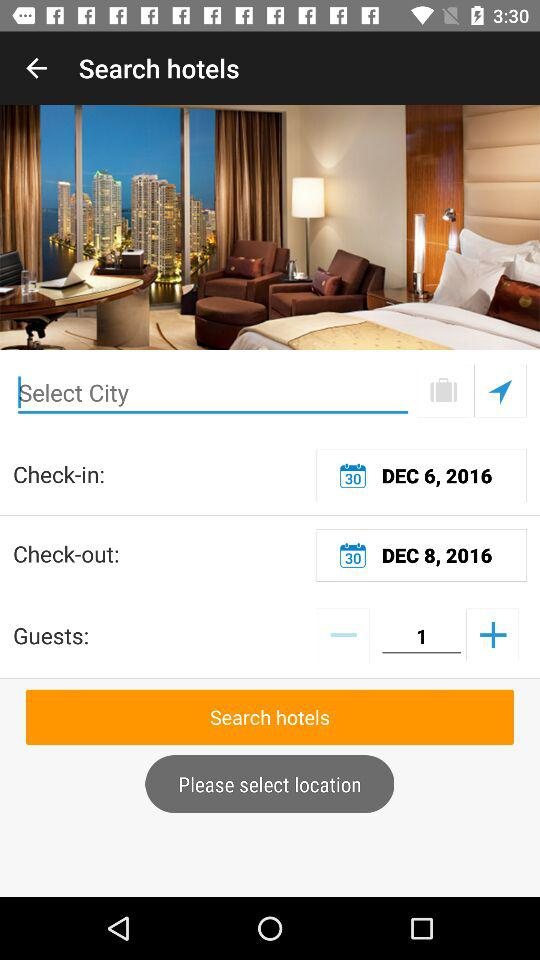How many guests are staying at the hotel?
Answer the question using a single word or phrase. 1 